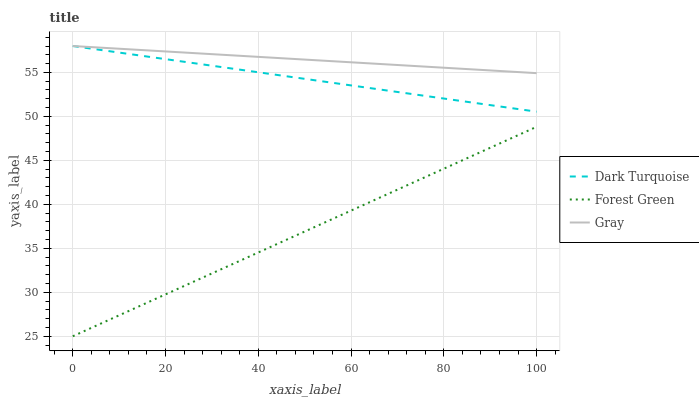Does Forest Green have the minimum area under the curve?
Answer yes or no. Yes. Does Gray have the maximum area under the curve?
Answer yes or no. Yes. Does Gray have the minimum area under the curve?
Answer yes or no. No. Does Forest Green have the maximum area under the curve?
Answer yes or no. No. Is Forest Green the smoothest?
Answer yes or no. Yes. Is Gray the roughest?
Answer yes or no. Yes. Is Gray the smoothest?
Answer yes or no. No. Is Forest Green the roughest?
Answer yes or no. No. Does Forest Green have the lowest value?
Answer yes or no. Yes. Does Gray have the lowest value?
Answer yes or no. No. Does Gray have the highest value?
Answer yes or no. Yes. Does Forest Green have the highest value?
Answer yes or no. No. Is Forest Green less than Gray?
Answer yes or no. Yes. Is Dark Turquoise greater than Forest Green?
Answer yes or no. Yes. Does Dark Turquoise intersect Gray?
Answer yes or no. Yes. Is Dark Turquoise less than Gray?
Answer yes or no. No. Is Dark Turquoise greater than Gray?
Answer yes or no. No. Does Forest Green intersect Gray?
Answer yes or no. No. 